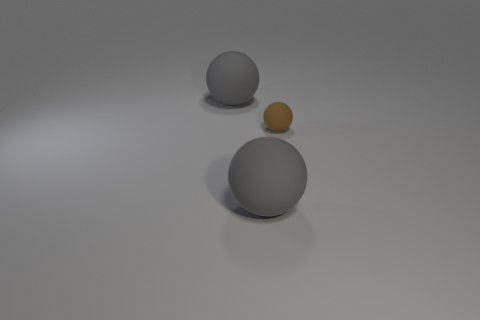Subtract all gray balls. How many balls are left? 1 Add 3 brown things. How many objects exist? 6 Subtract all large balls. How many balls are left? 1 Subtract 1 spheres. How many spheres are left? 2 Subtract all blue blocks. How many red balls are left? 0 Subtract 1 brown balls. How many objects are left? 2 Subtract all yellow spheres. Subtract all cyan cylinders. How many spheres are left? 3 Subtract all rubber spheres. Subtract all tiny cyan matte things. How many objects are left? 0 Add 3 gray matte spheres. How many gray matte spheres are left? 5 Add 2 tiny brown matte things. How many tiny brown matte things exist? 3 